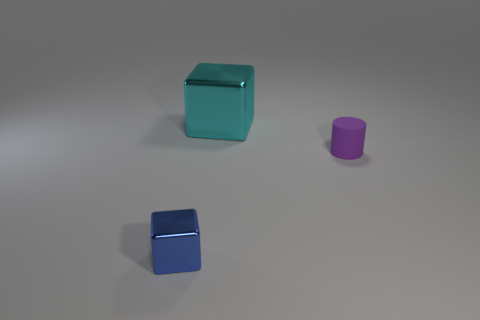Add 3 tiny purple spheres. How many objects exist? 6 Subtract all blocks. How many objects are left? 1 Add 3 tiny metal blocks. How many tiny metal blocks are left? 4 Add 1 green cubes. How many green cubes exist? 1 Subtract 1 blue cubes. How many objects are left? 2 Subtract all small blue cubes. Subtract all large brown objects. How many objects are left? 2 